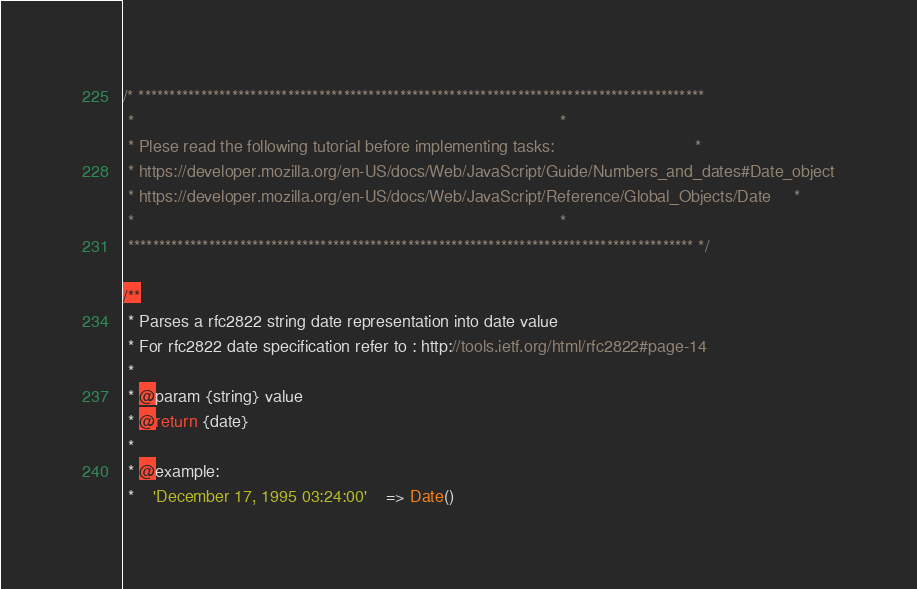Convert code to text. <code><loc_0><loc_0><loc_500><loc_500><_JavaScript_>/* *******************************************************************************************
 *                                                                                           *
 * Plese read the following tutorial before implementing tasks:                              *
 * https://developer.mozilla.org/en-US/docs/Web/JavaScript/Guide/Numbers_and_dates#Date_object
 * https://developer.mozilla.org/en-US/docs/Web/JavaScript/Reference/Global_Objects/Date     *
 *                                                                                           *
 ******************************************************************************************* */

/**
 * Parses a rfc2822 string date representation into date value
 * For rfc2822 date specification refer to : http://tools.ietf.org/html/rfc2822#page-14
 *
 * @param {string} value
 * @return {date}
 *
 * @example:
 *    'December 17, 1995 03:24:00'    => Date()</code> 